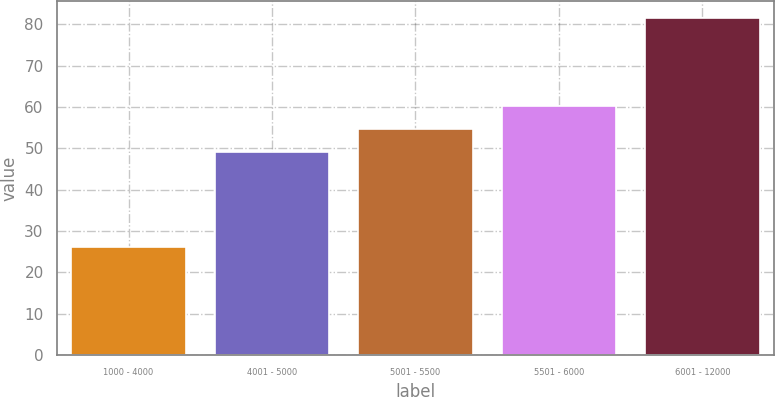Convert chart. <chart><loc_0><loc_0><loc_500><loc_500><bar_chart><fcel>1000 - 4000<fcel>4001 - 5000<fcel>5001 - 5500<fcel>5501 - 6000<fcel>6001 - 12000<nl><fcel>26.04<fcel>49.15<fcel>54.7<fcel>60.25<fcel>81.5<nl></chart> 